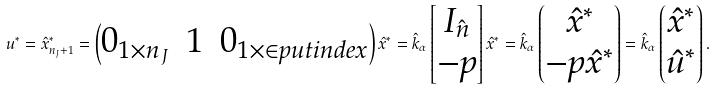<formula> <loc_0><loc_0><loc_500><loc_500>u ^ { * } = \hat { x } ^ { * } _ { n _ { J } + 1 } = \begin{pmatrix} 0 _ { 1 \times n _ { J } } & 1 & 0 _ { 1 \times \in p u t i n d e x } \end{pmatrix} \hat { x } ^ { * } = \hat { k } _ { \alpha } \begin{bmatrix} I _ { \hat { n } } \\ - p \end{bmatrix} \hat { x } ^ { * } = \hat { k } _ { \alpha } \begin{pmatrix} \hat { x } ^ { * } \\ - p \hat { x } ^ { * } \end{pmatrix} = \hat { k } _ { \alpha } \begin{pmatrix} \hat { x } ^ { * } \\ \hat { u } ^ { * } \end{pmatrix} .</formula> 